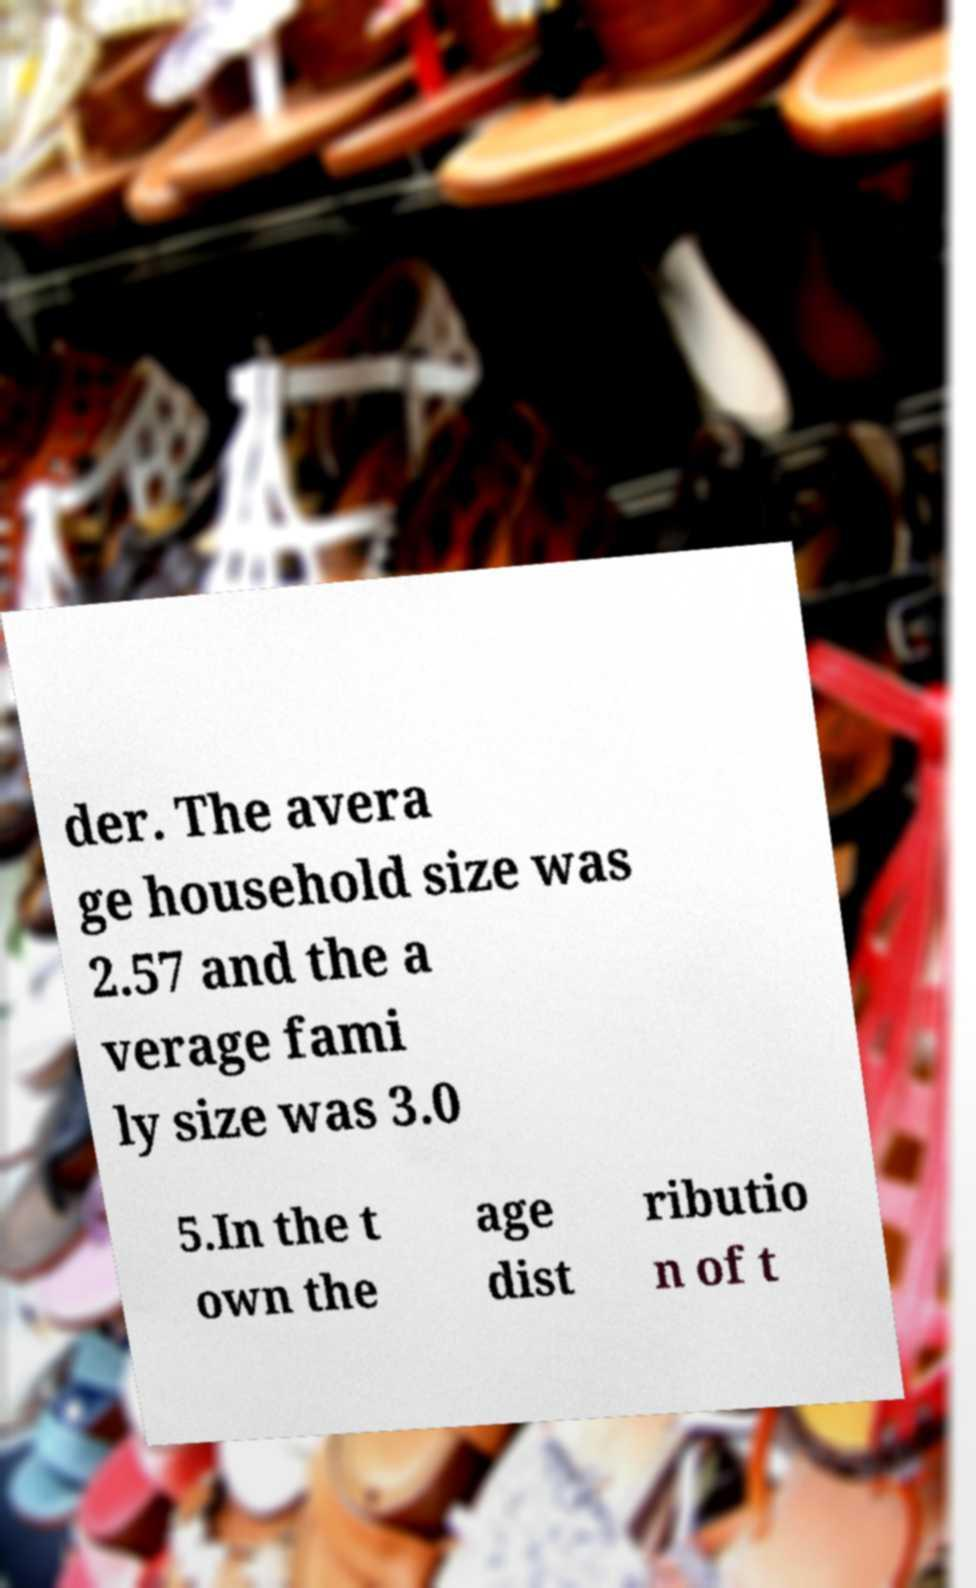Could you assist in decoding the text presented in this image and type it out clearly? der. The avera ge household size was 2.57 and the a verage fami ly size was 3.0 5.In the t own the age dist ributio n of t 